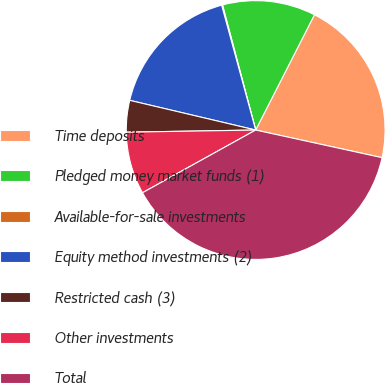<chart> <loc_0><loc_0><loc_500><loc_500><pie_chart><fcel>Time deposits<fcel>Pledged money market funds (1)<fcel>Available-for-sale investments<fcel>Equity method investments (2)<fcel>Restricted cash (3)<fcel>Other investments<fcel>Total<nl><fcel>20.92%<fcel>11.63%<fcel>0.11%<fcel>17.08%<fcel>3.95%<fcel>7.79%<fcel>38.52%<nl></chart> 